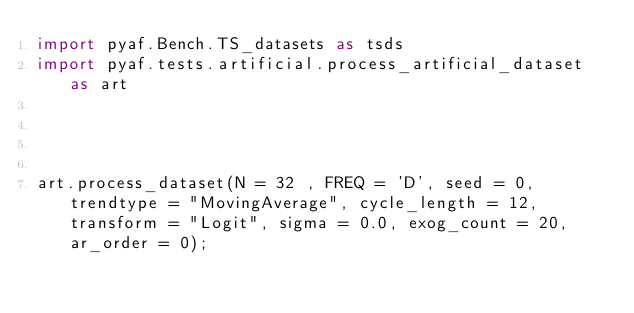Convert code to text. <code><loc_0><loc_0><loc_500><loc_500><_Python_>import pyaf.Bench.TS_datasets as tsds
import pyaf.tests.artificial.process_artificial_dataset as art




art.process_dataset(N = 32 , FREQ = 'D', seed = 0, trendtype = "MovingAverage", cycle_length = 12, transform = "Logit", sigma = 0.0, exog_count = 20, ar_order = 0);</code> 